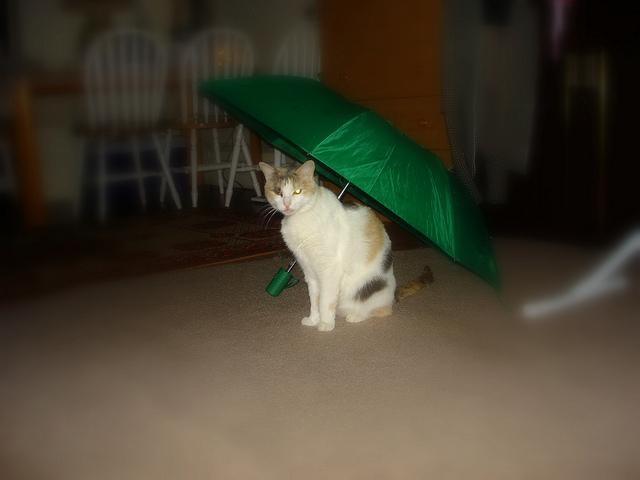What object used to prevent getting wet is nearby the cat in this image?
Select the accurate answer and provide explanation: 'Answer: answer
Rationale: rationale.'
Options: Chairs, carpet, umbrella, clothing. Answer: umbrella.
Rationale: The top part of that shields you from the rain. What is the white object to the right of the cat likely to be?
Choose the right answer and clarify with the format: 'Answer: answer
Rationale: rationale.'
Options: Bicycle, ironing board, table, toy. Answer: ironing board.
Rationale: The object is for ironing. 